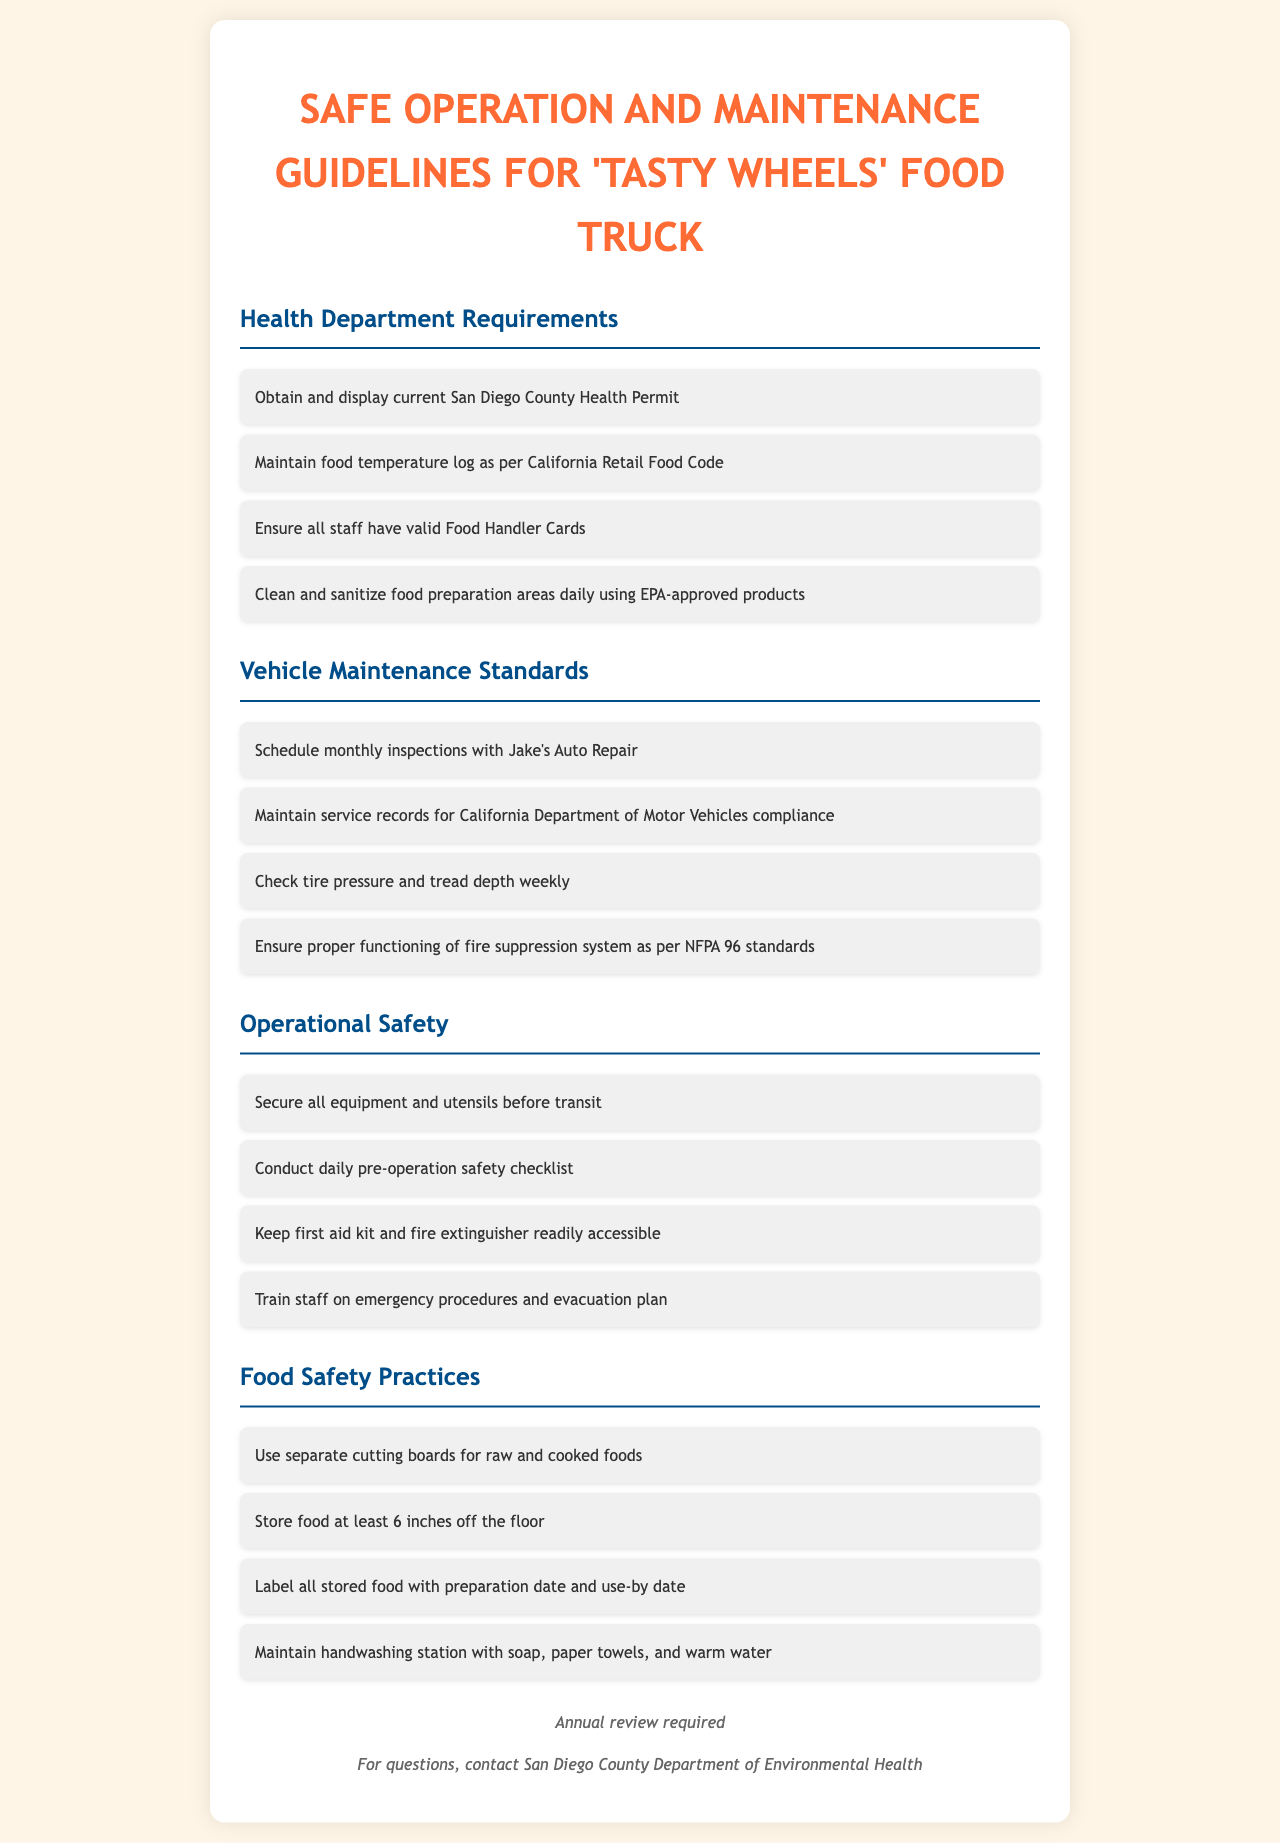What is required to operate the food truck legally? The health department requirements include displaying a current Health Permit, maintaining a food temperature log, ensuring staff have valid Food Handler Cards, and cleaning food preparation areas daily.
Answer: Current Health Permit How often should vehicle inspections be scheduled? The vehicle maintenance standards state to schedule inspections monthly.
Answer: Monthly What type of cards must all staff hold? The document specifies that all staff must have valid Food Handler Cards.
Answer: Food Handler Cards What should be checked weekly in vehicle maintenance? The guidelines indicate that tire pressure and tread depth should be checked weekly for safety.
Answer: Tire pressure and tread depth What is the minimum height to store food off the floor? Food should be stored at least six inches off the floor as per food safety practices.
Answer: Six inches What must be labeled with preparation and use-by dates? All stored food needs to be labeled with preparation and use-by dates, as highlighted in food safety practices.
Answer: Stored food What is the purpose of the daily pre-operation safety checklist? The operational safety guidelines require conducting a pre-operation safety checklist to ensure safety and readiness before operating the food truck.
Answer: Safety and readiness What should be located near the food truck for emergencies? The document mentions keeping a first aid kit and fire extinguisher readily accessible for emergencies.
Answer: First aid kit and fire extinguisher What must be ensured about the fire suppression system? The guidelines require ensuring proper functioning of the fire suppression system to comply with safety standards.
Answer: Proper functioning 